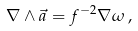Convert formula to latex. <formula><loc_0><loc_0><loc_500><loc_500>\nabla \wedge \vec { a } = f ^ { - 2 } \nabla \omega \, ,</formula> 